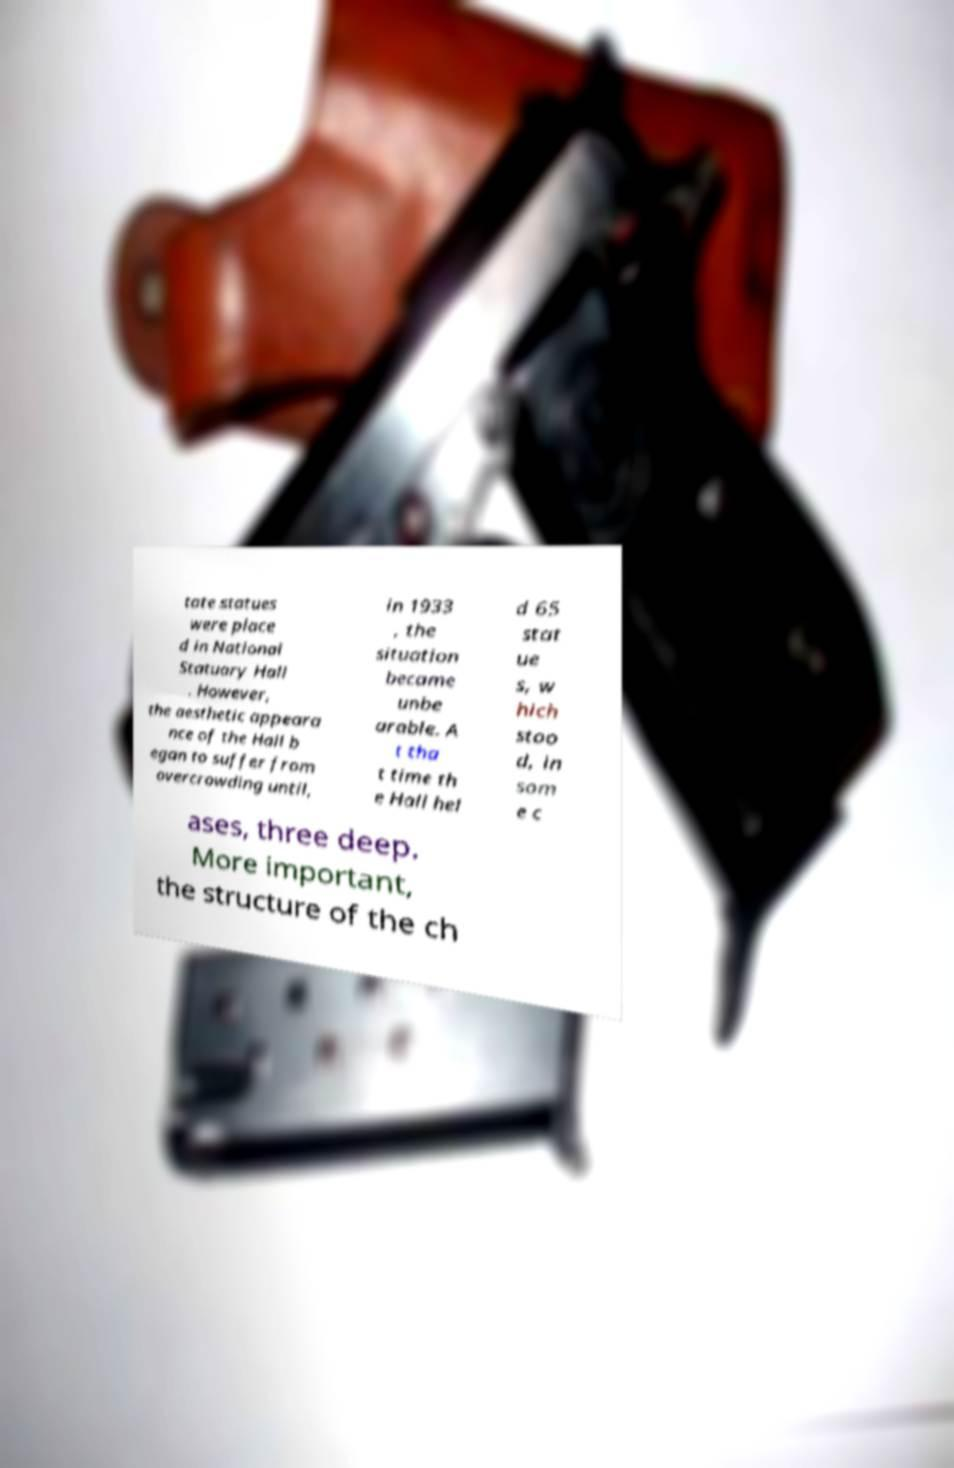Could you assist in decoding the text presented in this image and type it out clearly? tate statues were place d in National Statuary Hall . However, the aesthetic appeara nce of the Hall b egan to suffer from overcrowding until, in 1933 , the situation became unbe arable. A t tha t time th e Hall hel d 65 stat ue s, w hich stoo d, in som e c ases, three deep. More important, the structure of the ch 